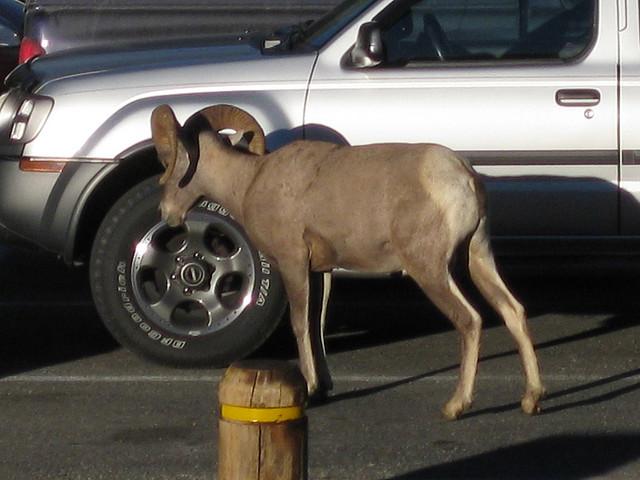How many people are in the car?
Quick response, please. 0. What is the antelope looking at?
Keep it brief. Tire. Is the vehicle moving?
Answer briefly. No. 